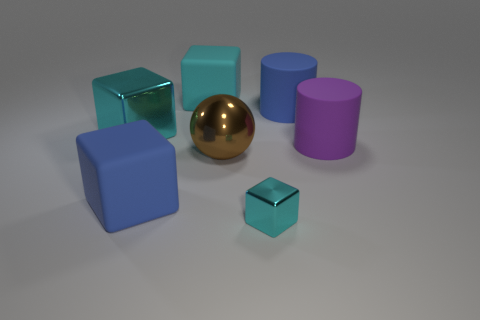Subtract 2 blocks. How many blocks are left? 2 Add 2 purple cylinders. How many objects exist? 9 Subtract all big blue blocks. How many blocks are left? 3 Add 5 large brown balls. How many large brown balls exist? 6 Subtract all cyan cubes. How many cubes are left? 1 Subtract 0 purple blocks. How many objects are left? 7 Subtract all balls. How many objects are left? 6 Subtract all blue cylinders. Subtract all purple cubes. How many cylinders are left? 1 Subtract all yellow cylinders. How many blue blocks are left? 1 Subtract all cyan shiny blocks. Subtract all purple rubber objects. How many objects are left? 4 